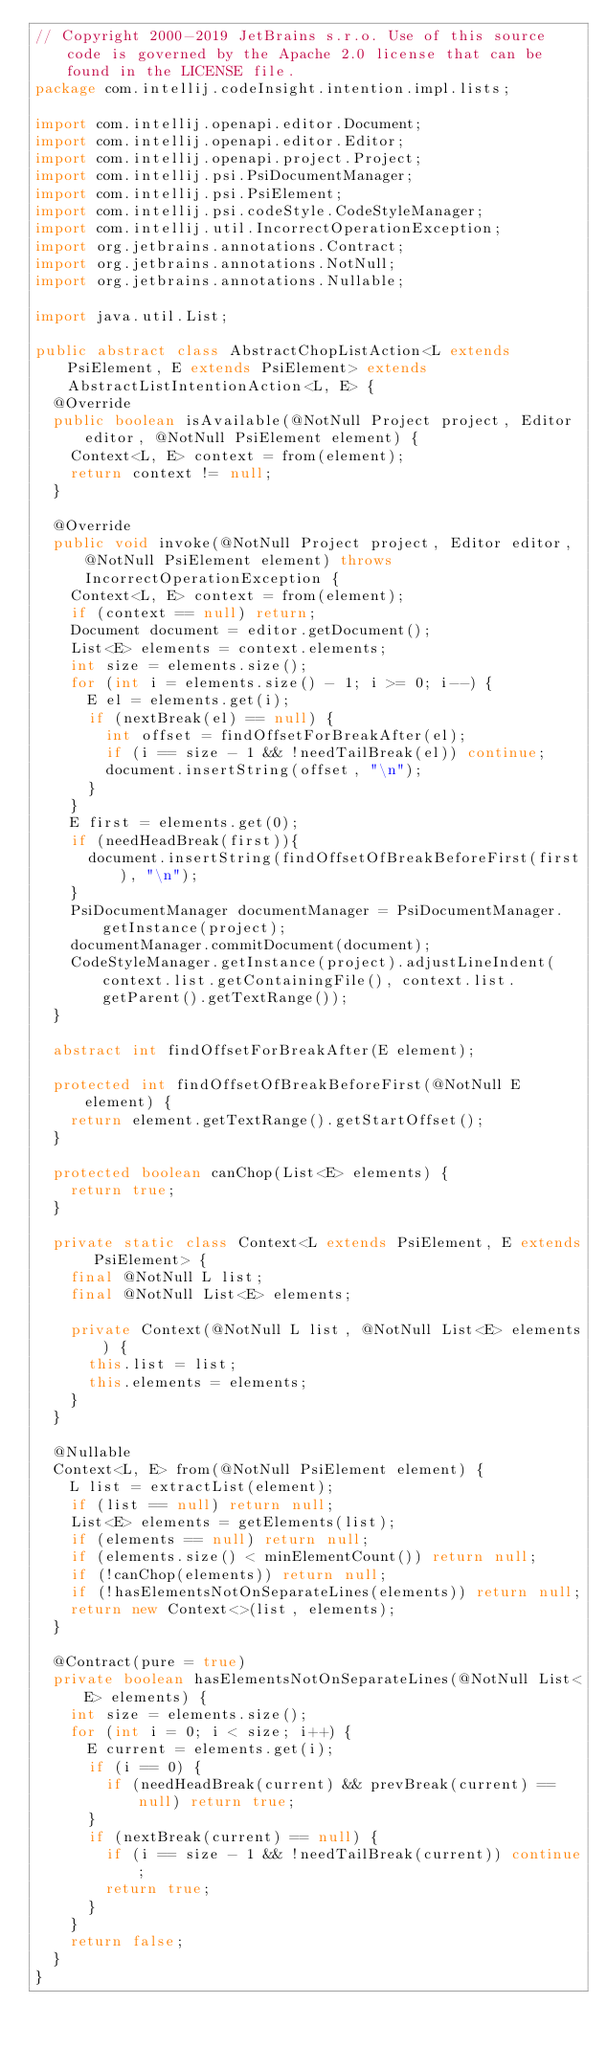Convert code to text. <code><loc_0><loc_0><loc_500><loc_500><_Java_>// Copyright 2000-2019 JetBrains s.r.o. Use of this source code is governed by the Apache 2.0 license that can be found in the LICENSE file.
package com.intellij.codeInsight.intention.impl.lists;

import com.intellij.openapi.editor.Document;
import com.intellij.openapi.editor.Editor;
import com.intellij.openapi.project.Project;
import com.intellij.psi.PsiDocumentManager;
import com.intellij.psi.PsiElement;
import com.intellij.psi.codeStyle.CodeStyleManager;
import com.intellij.util.IncorrectOperationException;
import org.jetbrains.annotations.Contract;
import org.jetbrains.annotations.NotNull;
import org.jetbrains.annotations.Nullable;

import java.util.List;

public abstract class AbstractChopListAction<L extends PsiElement, E extends PsiElement> extends AbstractListIntentionAction<L, E> {
  @Override
  public boolean isAvailable(@NotNull Project project, Editor editor, @NotNull PsiElement element) {
    Context<L, E> context = from(element);
    return context != null;
  }

  @Override
  public void invoke(@NotNull Project project, Editor editor, @NotNull PsiElement element) throws IncorrectOperationException {
    Context<L, E> context = from(element);
    if (context == null) return;
    Document document = editor.getDocument();
    List<E> elements = context.elements;
    int size = elements.size();
    for (int i = elements.size() - 1; i >= 0; i--) {
      E el = elements.get(i);
      if (nextBreak(el) == null) {
        int offset = findOffsetForBreakAfter(el);
        if (i == size - 1 && !needTailBreak(el)) continue;
        document.insertString(offset, "\n");
      }
    }
    E first = elements.get(0);
    if (needHeadBreak(first)){
      document.insertString(findOffsetOfBreakBeforeFirst(first), "\n");
    }
    PsiDocumentManager documentManager = PsiDocumentManager.getInstance(project);
    documentManager.commitDocument(document);
    CodeStyleManager.getInstance(project).adjustLineIndent(context.list.getContainingFile(), context.list.getParent().getTextRange());
  }

  abstract int findOffsetForBreakAfter(E element);

  protected int findOffsetOfBreakBeforeFirst(@NotNull E element) {
    return element.getTextRange().getStartOffset();
  }

  protected boolean canChop(List<E> elements) {
    return true;
  }

  private static class Context<L extends PsiElement, E extends PsiElement> {
    final @NotNull L list;
    final @NotNull List<E> elements;

    private Context(@NotNull L list, @NotNull List<E> elements) {
      this.list = list;
      this.elements = elements;
    }
  }

  @Nullable
  Context<L, E> from(@NotNull PsiElement element) {
    L list = extractList(element);
    if (list == null) return null;
    List<E> elements = getElements(list);
    if (elements == null) return null;
    if (elements.size() < minElementCount()) return null;
    if (!canChop(elements)) return null;
    if (!hasElementsNotOnSeparateLines(elements)) return null;
    return new Context<>(list, elements);
  }

  @Contract(pure = true)
  private boolean hasElementsNotOnSeparateLines(@NotNull List<E> elements) {
    int size = elements.size();
    for (int i = 0; i < size; i++) {
      E current = elements.get(i);
      if (i == 0) {
        if (needHeadBreak(current) && prevBreak(current) == null) return true;
      }
      if (nextBreak(current) == null) {
        if (i == size - 1 && !needTailBreak(current)) continue;
        return true;
      }
    }
    return false;
  }
}
</code> 